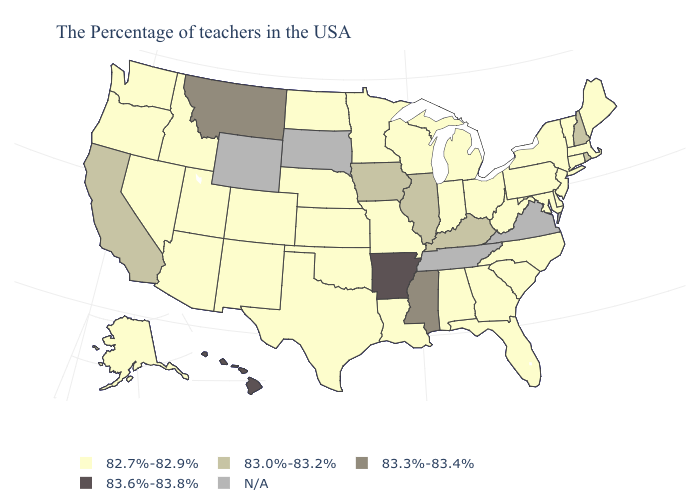Name the states that have a value in the range 83.3%-83.4%?
Give a very brief answer. Mississippi, Montana. What is the value of Arkansas?
Concise answer only. 83.6%-83.8%. Does New Hampshire have the lowest value in the USA?
Give a very brief answer. No. Which states have the lowest value in the USA?
Short answer required. Maine, Massachusetts, Vermont, Connecticut, New York, New Jersey, Delaware, Maryland, Pennsylvania, North Carolina, South Carolina, West Virginia, Ohio, Florida, Georgia, Michigan, Indiana, Alabama, Wisconsin, Louisiana, Missouri, Minnesota, Kansas, Nebraska, Oklahoma, Texas, North Dakota, Colorado, New Mexico, Utah, Arizona, Idaho, Nevada, Washington, Oregon, Alaska. Which states have the highest value in the USA?
Quick response, please. Arkansas, Hawaii. Name the states that have a value in the range N/A?
Give a very brief answer. Virginia, Tennessee, South Dakota, Wyoming. What is the value of Maryland?
Write a very short answer. 82.7%-82.9%. Name the states that have a value in the range 83.0%-83.2%?
Answer briefly. Rhode Island, New Hampshire, Kentucky, Illinois, Iowa, California. What is the lowest value in the South?
Answer briefly. 82.7%-82.9%. Name the states that have a value in the range 83.3%-83.4%?
Short answer required. Mississippi, Montana. Name the states that have a value in the range 82.7%-82.9%?
Quick response, please. Maine, Massachusetts, Vermont, Connecticut, New York, New Jersey, Delaware, Maryland, Pennsylvania, North Carolina, South Carolina, West Virginia, Ohio, Florida, Georgia, Michigan, Indiana, Alabama, Wisconsin, Louisiana, Missouri, Minnesota, Kansas, Nebraska, Oklahoma, Texas, North Dakota, Colorado, New Mexico, Utah, Arizona, Idaho, Nevada, Washington, Oregon, Alaska. Among the states that border West Virginia , which have the lowest value?
Short answer required. Maryland, Pennsylvania, Ohio. Does Hawaii have the highest value in the West?
Answer briefly. Yes. Name the states that have a value in the range 82.7%-82.9%?
Give a very brief answer. Maine, Massachusetts, Vermont, Connecticut, New York, New Jersey, Delaware, Maryland, Pennsylvania, North Carolina, South Carolina, West Virginia, Ohio, Florida, Georgia, Michigan, Indiana, Alabama, Wisconsin, Louisiana, Missouri, Minnesota, Kansas, Nebraska, Oklahoma, Texas, North Dakota, Colorado, New Mexico, Utah, Arizona, Idaho, Nevada, Washington, Oregon, Alaska. What is the value of California?
Give a very brief answer. 83.0%-83.2%. 